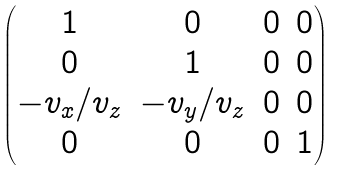<formula> <loc_0><loc_0><loc_500><loc_500>\begin{pmatrix} 1 & 0 & 0 & 0 \\ 0 & 1 & 0 & 0 \\ { - v _ { x } } / { v _ { z } } & { - v _ { y } } / { v _ { z } } & 0 & 0 \\ 0 & 0 & 0 & 1 \\ \end{pmatrix}</formula> 